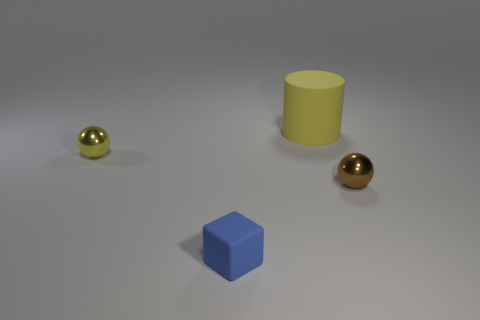Subtract all purple cylinders. Subtract all brown cubes. How many cylinders are left? 1 Add 3 brown metal things. How many objects exist? 7 Subtract all cubes. How many objects are left? 3 Add 1 yellow matte things. How many yellow matte things exist? 2 Subtract 0 purple cylinders. How many objects are left? 4 Subtract all yellow matte cylinders. Subtract all tiny yellow objects. How many objects are left? 2 Add 2 small metal spheres. How many small metal spheres are left? 4 